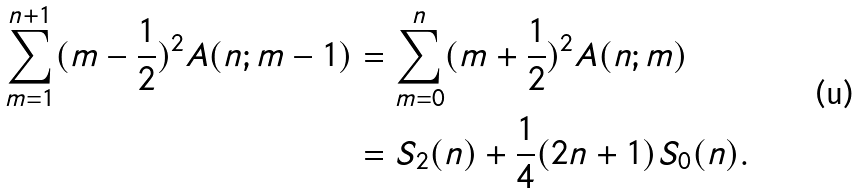<formula> <loc_0><loc_0><loc_500><loc_500>\sum _ { m = 1 } ^ { n + 1 } ( m - \frac { 1 } { 2 } ) ^ { 2 } A ( n ; m - 1 ) & = \sum _ { m = 0 } ^ { n } ( m + \frac { 1 } { 2 } ) ^ { 2 } A ( n ; m ) \\ & = S _ { 2 } ( n ) + \frac { 1 } { 4 } ( 2 n + 1 ) S _ { 0 } ( n ) .</formula> 